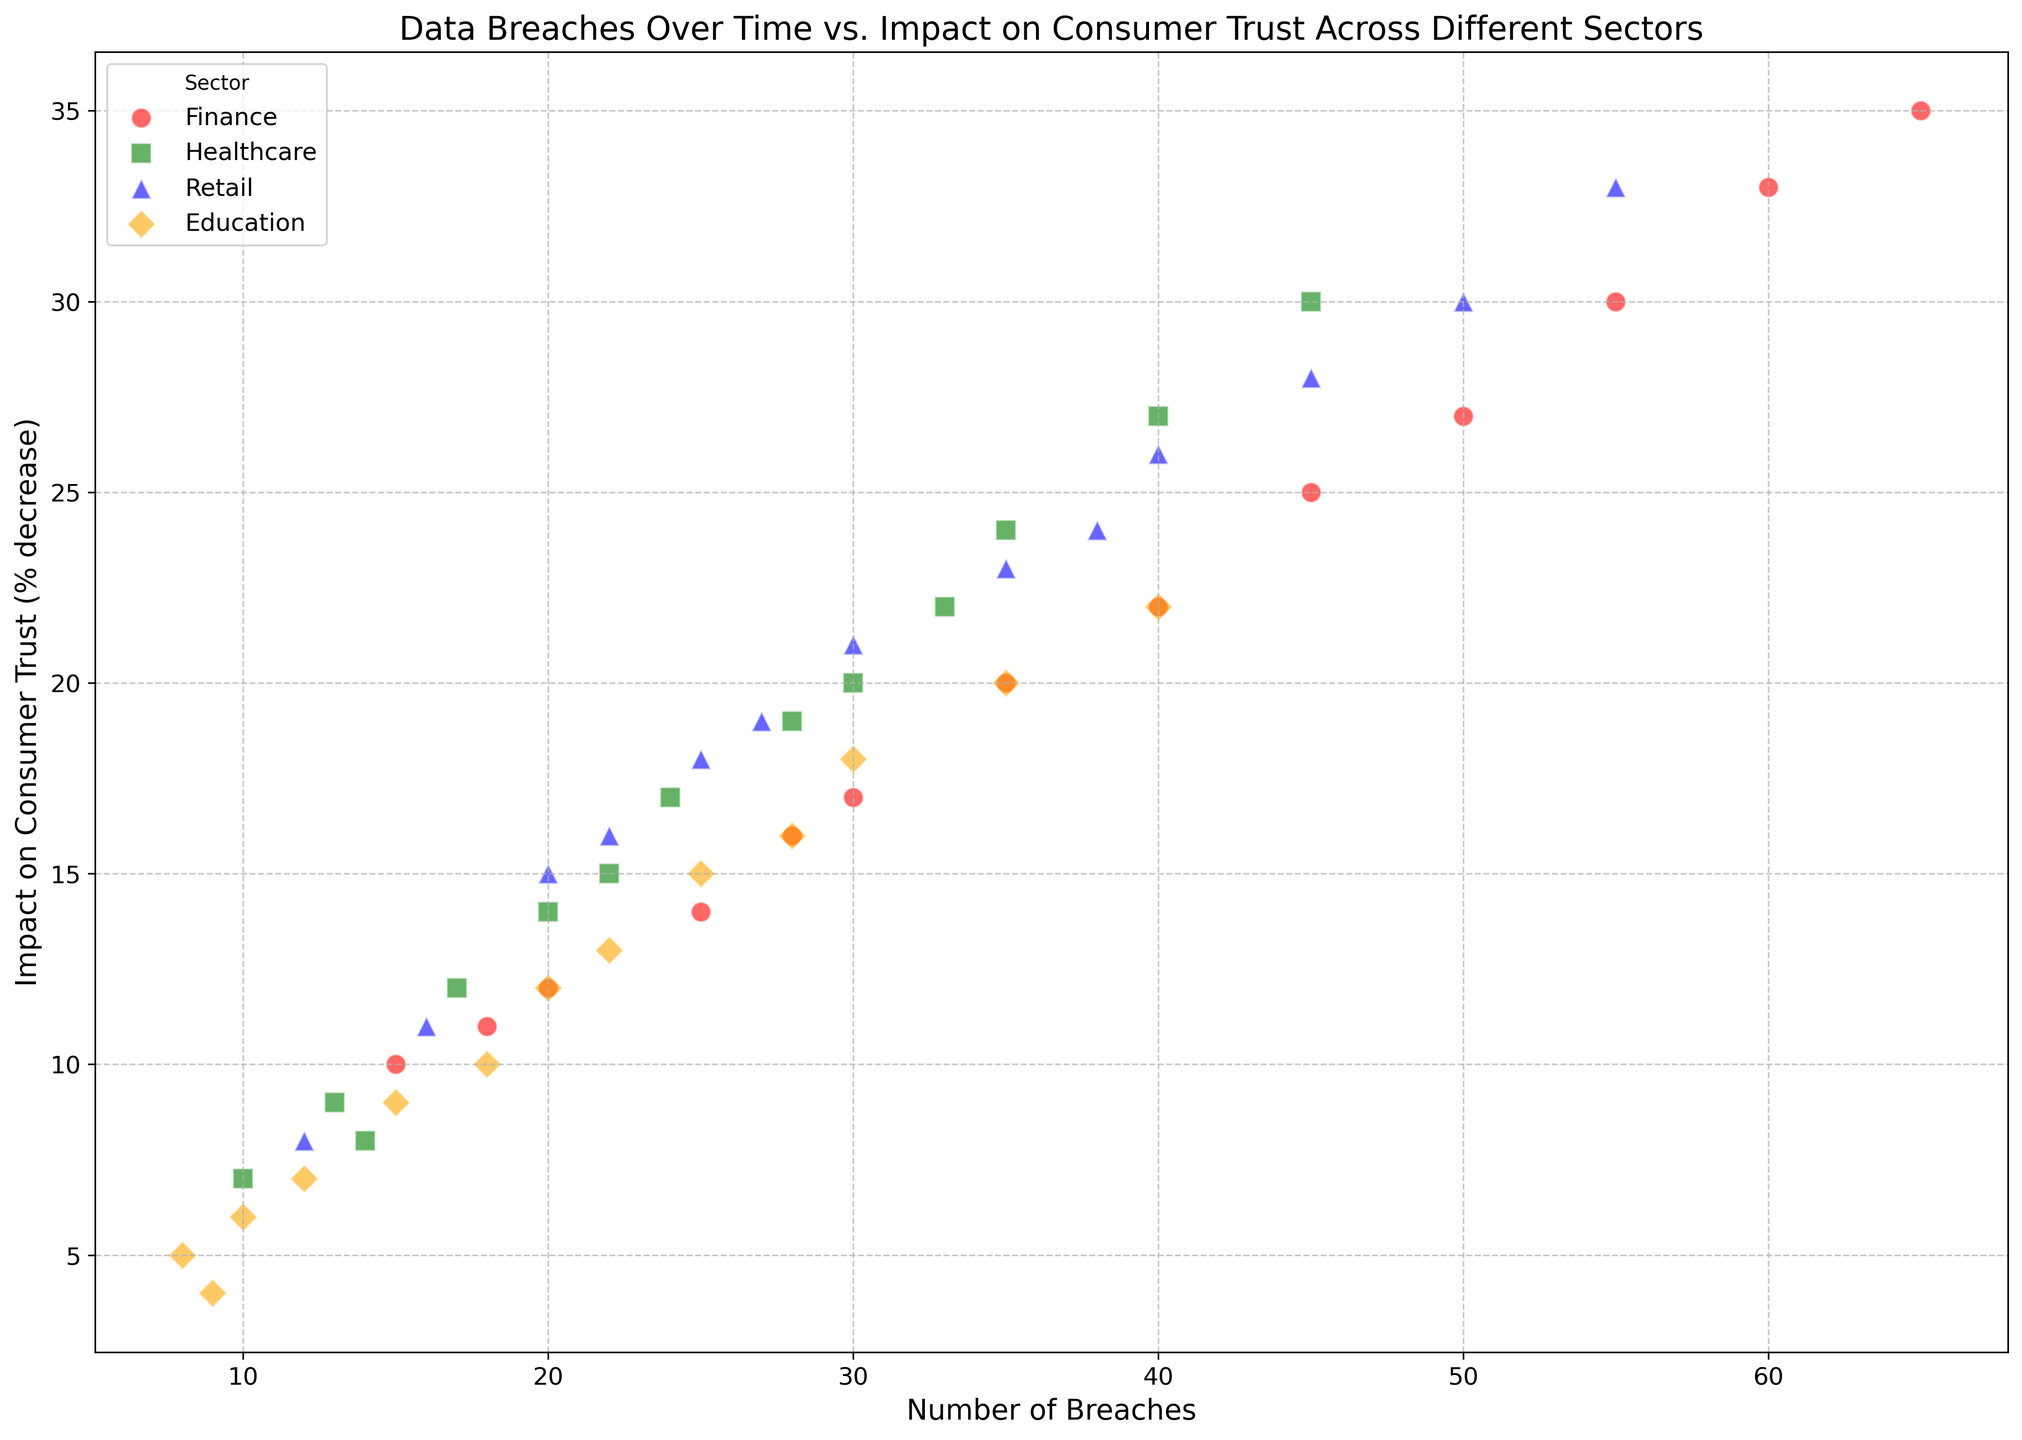What is the trend of impact on consumer trust in the finance sector over time? To determine the trend, look at the data points for the finance sector marked in one color along the timeline from 2010 to 2022. The impact on consumer trust consistently increases over this period.
Answer: Increasing Which sector experienced the highest impact on consumer trust in 2022? To identify this, compare the highest data points for each sector in 2022. The retail sector has the highest value.
Answer: Retail What is the difference in the number of data breaches between the finance sector and the education sector in 2021? Locate the data points for the finance and education sectors for the year 2021. Finance had 60 breaches, and education had 35 breaches. The difference is 60 - 35.
Answer: 25 Which sector shows the steepest increase in consumer trust impact per breach from 2010 to 2022? Compare the slopes of the lines formed by connecting the data points for each sector from 2010 to 2022. The finance sector shows the steepest slope, indicating the steepest increase.
Answer: Finance How many more breaches did the healthcare sector experience in 2020 compared to 2010? Note the number of breaches in healthcare for 2010 and 2020. In 2010, there were 10 breaches; in 2020, there were 35 breaches. The difference is 35 - 10.
Answer: 25 Which sector has the highest variation in the number of breaches over the years? To determine this, observe the range of the number of breaches for each sector. The finance sector shows the greatest range from 15 breaches in 2010 to 65 breaches in 2022.
Answer: Finance What is the average impact on consumer trust across all sectors in 2019? Take the 2019 values for all sectors and average them: (27 + 22 + 26 + 16) / 4. This equals (91 / 4).
Answer: 22.75 Which sector has a similar number of breaches and impact on consumer trust in both 2011 and 2012? Compare data points for each sector in 2011 and 2012. The education sector has close values with breaches of 10 and 9, and trust impacts of 6 and 4.
Answer: Education How does the impact on consumer trust in the retail sector in 2018 compare with that in 2012? Refer to the scatter plot for 2018 and 2012 data points in retail. In 2012, the impact was 15%. In 2018, it was 24%. The impact is higher in 2018.
Answer: Higher When did the healthcare sector see a 20% impact on consumer trust? Find the data point where the healthcare sector reaches 20% on the Y-axis. It appears in the year 2018.
Answer: 2018 